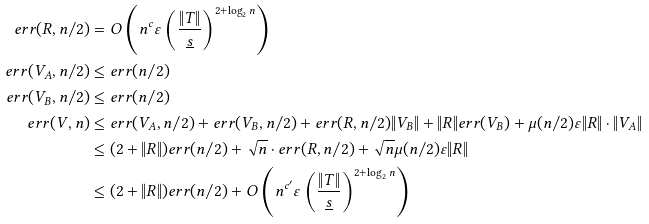Convert formula to latex. <formula><loc_0><loc_0><loc_500><loc_500>e r r ( R , n / 2 ) & = O \left ( n ^ { c } \varepsilon \left ( \frac { \| T \| } { \underline { s } } \right ) ^ { 2 + \log _ { 2 } n } \right ) \\ e r r ( V _ { A } , n / 2 ) & \leq e r r ( n / 2 ) \\ e r r ( V _ { B } , n / 2 ) & \leq e r r ( n / 2 ) \\ e r r ( V , n ) & \leq e r r ( V _ { A } , n / 2 ) + e r r ( V _ { B } , n / 2 ) + e r r ( R , n / 2 ) \| V _ { B } \| + \| R \| e r r ( V _ { B } ) + \mu ( n / 2 ) \varepsilon \| R \| \cdot \| V _ { A } \| \\ & \leq ( 2 + \| R \| ) e r r ( n / 2 ) + \sqrt { n } \cdot e r r ( R , n / 2 ) + \sqrt { n } \mu ( n / 2 ) \varepsilon \| R \| \\ & \leq ( 2 + \| R \| ) e r r ( n / 2 ) + O \left ( n ^ { c ^ { \prime } } \varepsilon \left ( \frac { \| T \| } { \underline { s } } \right ) ^ { 2 + \log _ { 2 } n } \right ) \\</formula> 